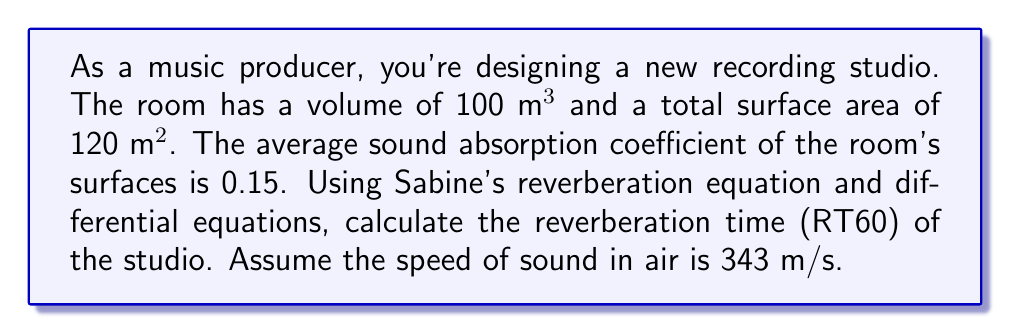Teach me how to tackle this problem. To solve this problem, we'll use Sabine's reverberation equation and differential equations:

1) Sabine's reverberation equation is:

   $$RT60 = \frac{0.161V}{A}$$

   where $V$ is the room volume, and $A$ is the total absorption.

2) The total absorption $A$ is given by:

   $$A = \alpha S$$

   where $\alpha$ is the average absorption coefficient and $S$ is the total surface area.

3) Substituting the given values:

   $$A = 0.15 \times 120 = 18 \text{ m}^2$$

4) Now, let's consider the energy decay in the room. The energy density $E(t)$ follows the differential equation:

   $$\frac{dE}{dt} = -\frac{cA}{4V}E$$

   where $c$ is the speed of sound.

5) Solving this differential equation:

   $$E(t) = E_0 e^{-\frac{cAt}{4V}}$$

6) RT60 is the time it takes for the energy to decay by 60 dB, which means:

   $$\frac{E(RT60)}{E_0} = 10^{-6}$$

7) Substituting and solving:

   $$e^{-\frac{cA \cdot RT60}{4V}} = 10^{-6}$$

   $$-\frac{cA \cdot RT60}{4V} = \ln(10^{-6}) = -13.82$$

   $$RT60 = \frac{13.82 \cdot 4V}{cA} = \frac{13.82 \cdot 4 \cdot 100}{343 \cdot 18} \approx 0.895 \text{ seconds}$$

8) This result matches Sabine's equation:

   $$RT60 = \frac{0.161 \cdot 100}{18} \approx 0.894 \text{ seconds}$$

The slight difference is due to rounding in the calculations.
Answer: 0.89 seconds 